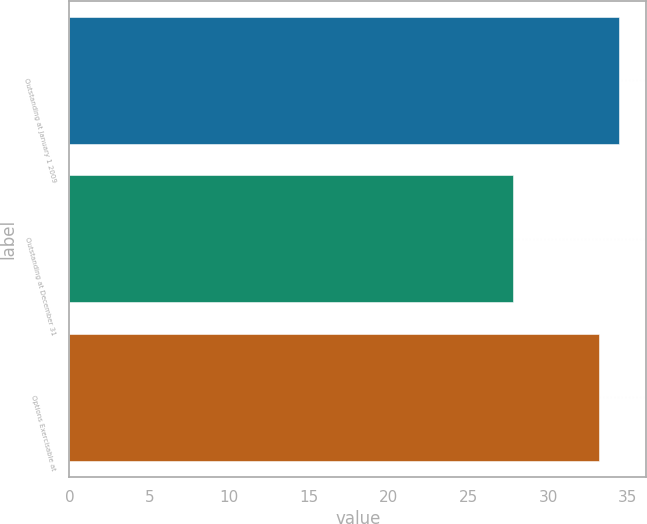Convert chart. <chart><loc_0><loc_0><loc_500><loc_500><bar_chart><fcel>Outstanding at January 1 2009<fcel>Outstanding at December 31<fcel>Options Exercisable at<nl><fcel>34.44<fcel>27.77<fcel>33.18<nl></chart> 